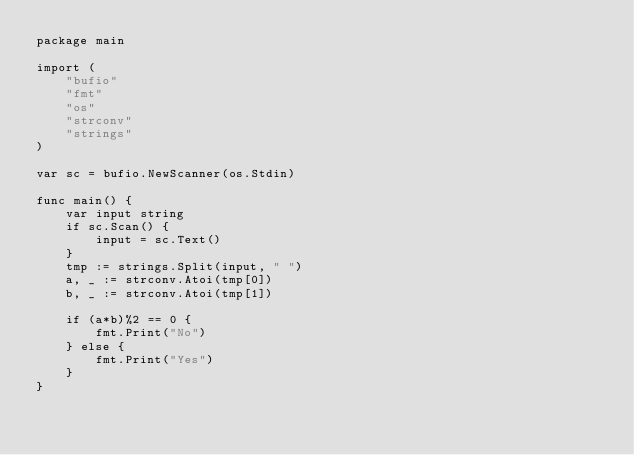Convert code to text. <code><loc_0><loc_0><loc_500><loc_500><_Go_>package main

import (
	"bufio"
	"fmt"
	"os"
	"strconv"
	"strings"
)

var sc = bufio.NewScanner(os.Stdin)

func main() {
	var input string
	if sc.Scan() {
		input = sc.Text()
	}
	tmp := strings.Split(input, " ")
	a, _ := strconv.Atoi(tmp[0])
	b, _ := strconv.Atoi(tmp[1])

	if (a*b)%2 == 0 {
		fmt.Print("No")
	} else {
		fmt.Print("Yes")
	}
}
</code> 